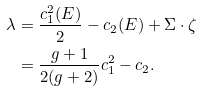Convert formula to latex. <formula><loc_0><loc_0><loc_500><loc_500>\lambda & = \frac { c _ { 1 } ^ { 2 } ( E ) } { 2 } - c _ { 2 } ( E ) + \Sigma \cdot \zeta \\ & = \frac { g + 1 } { 2 ( g + 2 ) } c _ { 1 } ^ { 2 } - c _ { 2 } .</formula> 